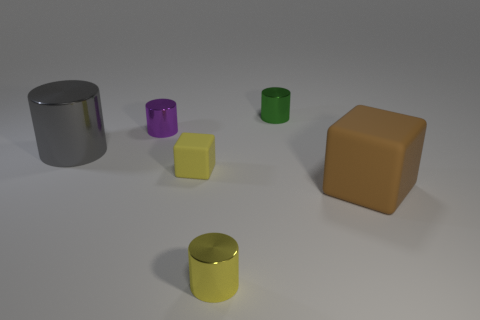There is a block that is in front of the small yellow cube; does it have the same size as the rubber thing that is to the left of the green cylinder? No, the block in front of the small yellow cube does not have the same size as the rubber object to the left of the green cylinder. The block in question is a larger, yellow cube compared to the smaller, purple cylindrical object. 